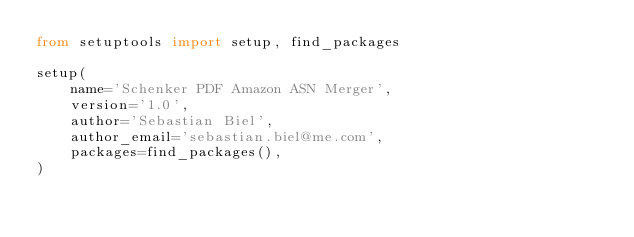Convert code to text. <code><loc_0><loc_0><loc_500><loc_500><_Python_>from setuptools import setup, find_packages

setup(
    name='Schenker PDF Amazon ASN Merger',
    version='1.0',
    author='Sebastian Biel',
    author_email='sebastian.biel@me.com',
    packages=find_packages(),
)
</code> 